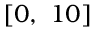Convert formula to latex. <formula><loc_0><loc_0><loc_500><loc_500>[ 0 , \ 1 0 ]</formula> 